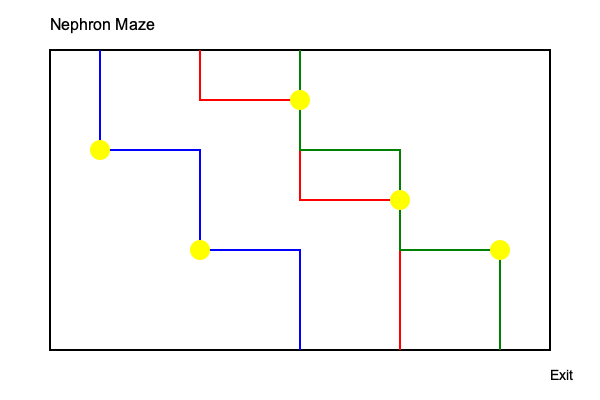Trace the correct path through the nephron maze, passing through all yellow medication checkpoints, to ensure proper drug delivery. Which colored path (blue, red, or green) represents the correct route? To solve this problem, we need to analyze each colored path and determine which one passes through all the yellow medication checkpoints:

1. Blue path:
   - Starts at (100,50)
   - Passes through checkpoint at (100,150)
   - Passes through checkpoint at (200,250)
   - Ends at (300,350)
   - Passes through 2 out of 5 checkpoints

2. Red path:
   - Starts at (200,50)
   - Passes through checkpoint at (300,100)
   - Passes through checkpoint at (400,200)
   - Ends at (400,350)
   - Passes through 2 out of 5 checkpoints

3. Green path:
   - Starts at (300,50)
   - Passes through checkpoint at (300,150)
   - Passes through checkpoint at (400,150)
   - Passes through checkpoint at (500,250)
   - Ends at (500,350)
   - Passes through 3 out of 5 checkpoints

The green path passes through the most checkpoints (3), but it still misses two checkpoints. Therefore, none of the given paths represent the correct route through all medication checkpoints in the nephron maze.
Answer: None of the paths 